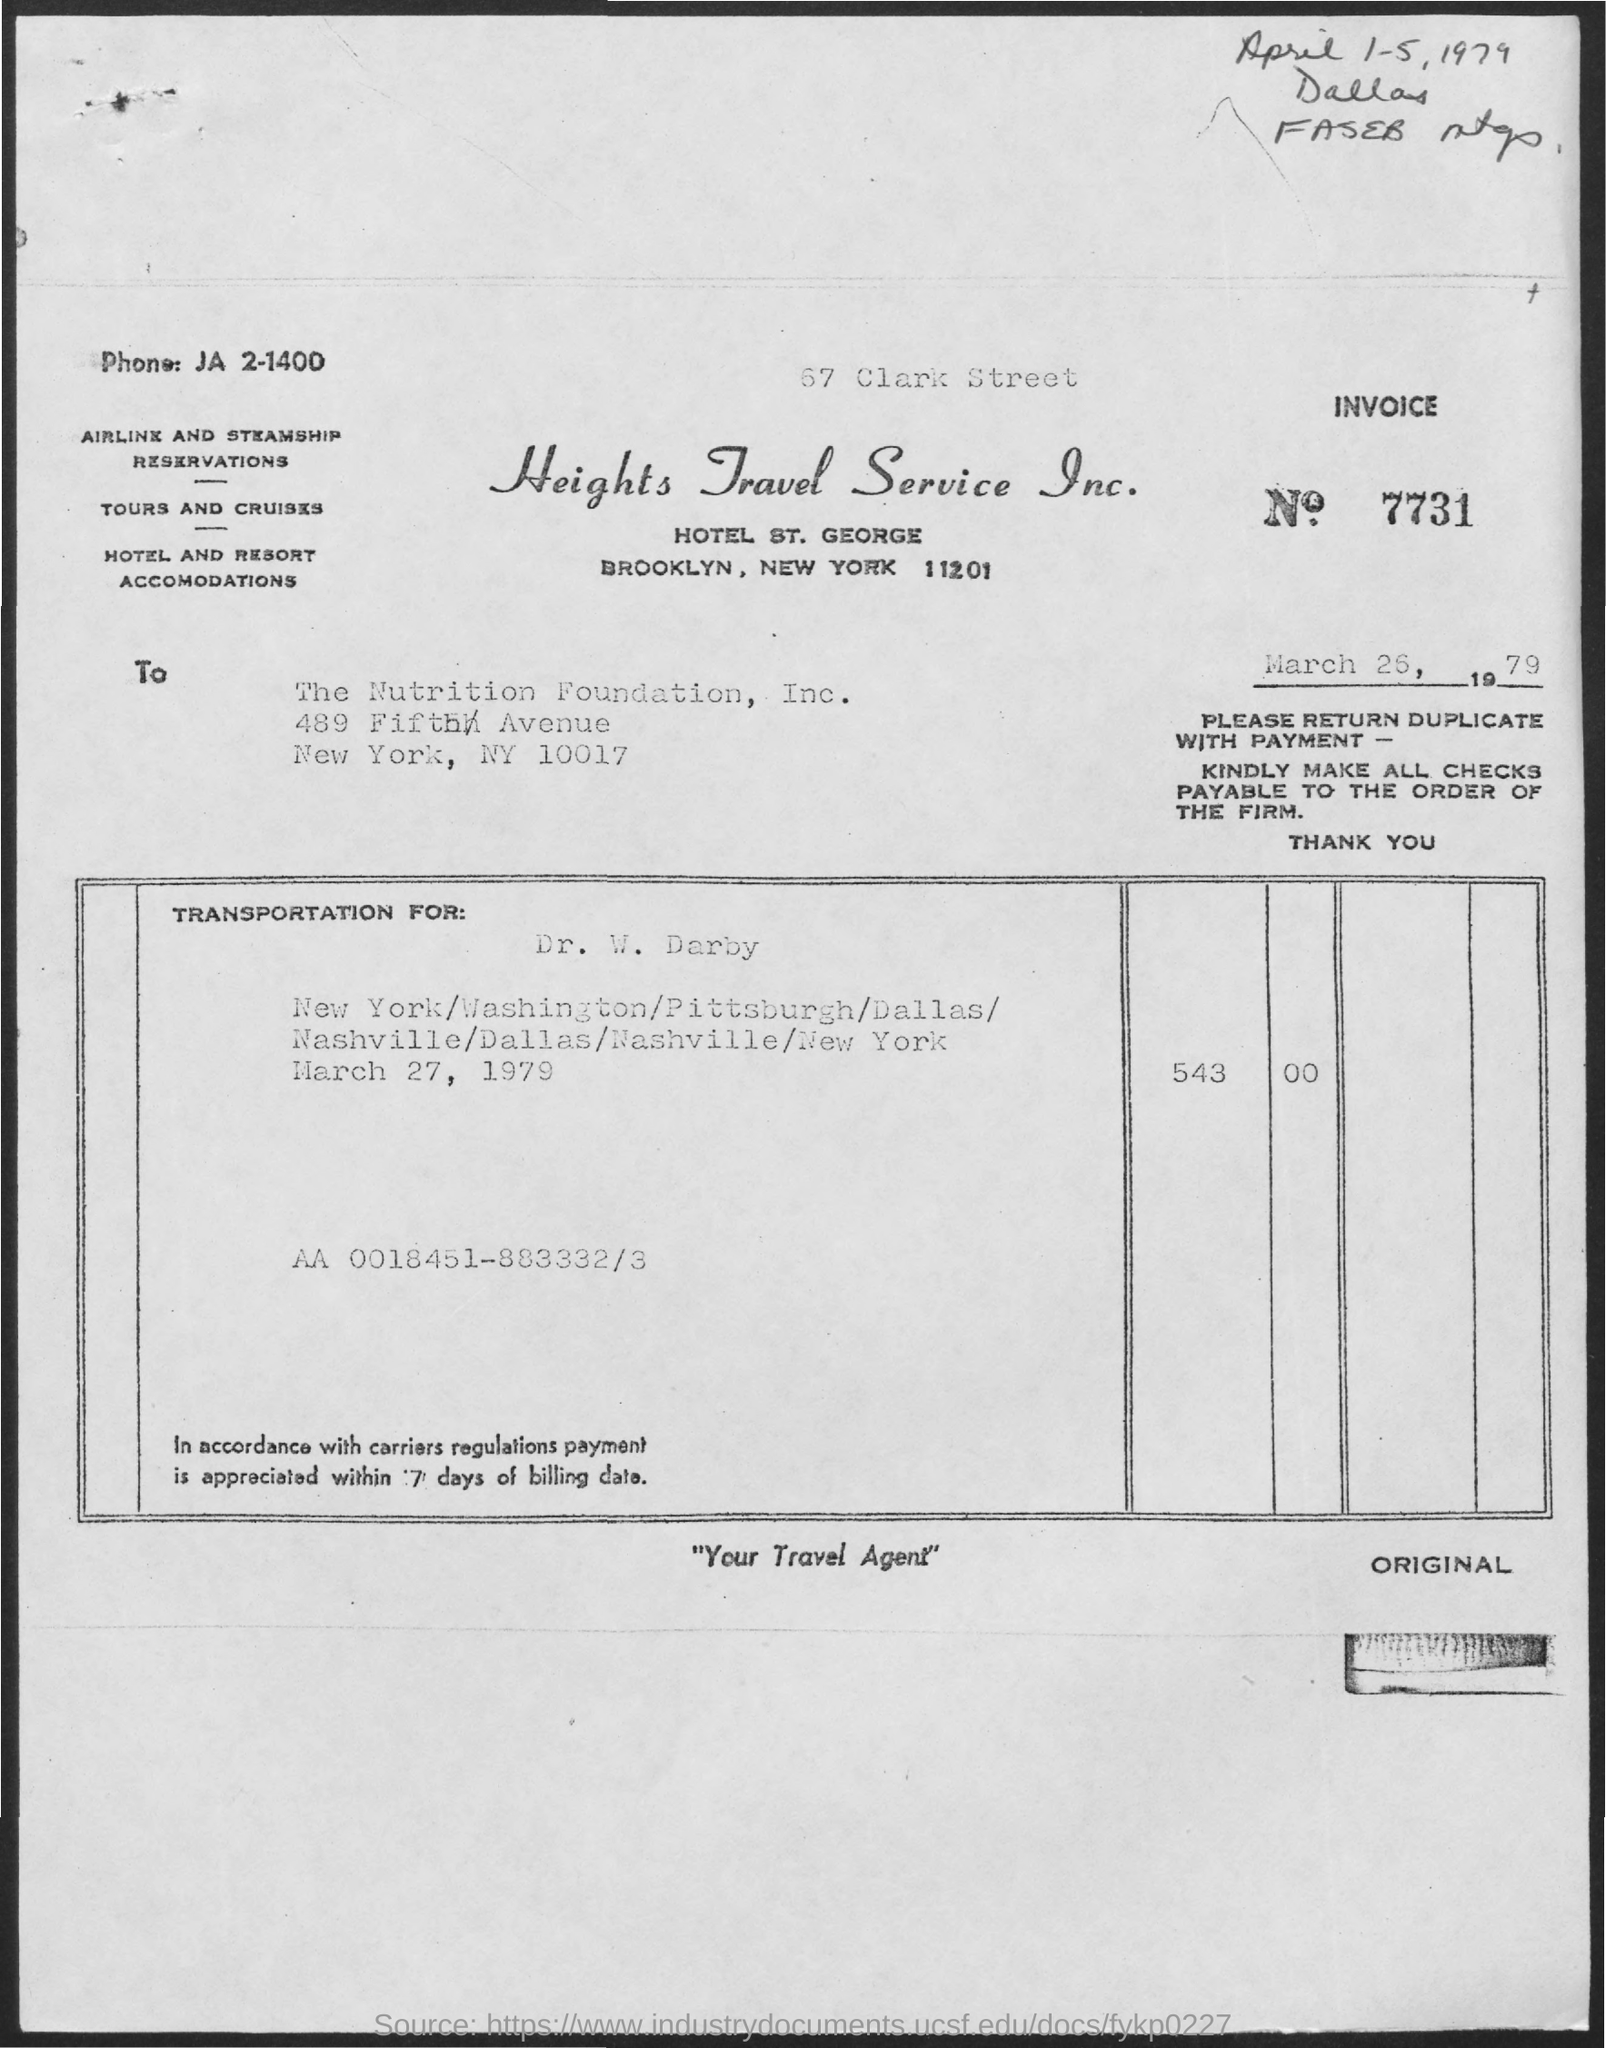What is the INVOICE number ?
Your answer should be very brief. 7731. What is the Phone Number ?
Keep it short and to the point. JA 2-1400. 